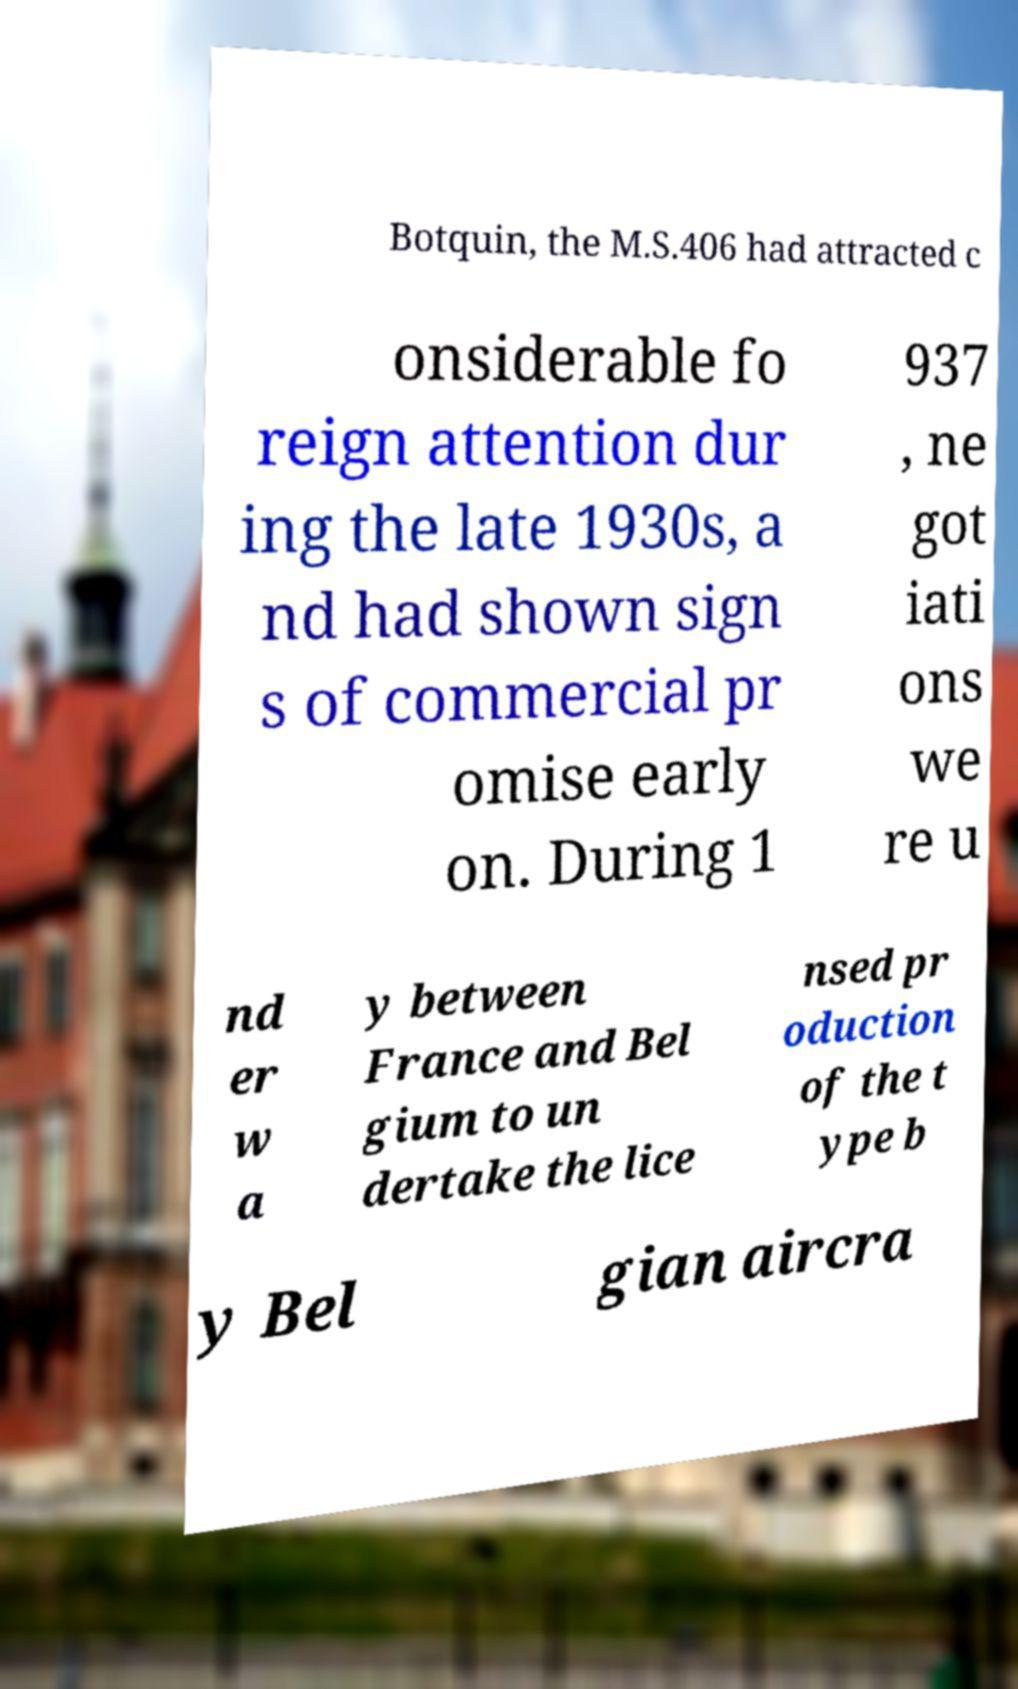Can you read and provide the text displayed in the image?This photo seems to have some interesting text. Can you extract and type it out for me? Botquin, the M.S.406 had attracted c onsiderable fo reign attention dur ing the late 1930s, a nd had shown sign s of commercial pr omise early on. During 1 937 , ne got iati ons we re u nd er w a y between France and Bel gium to un dertake the lice nsed pr oduction of the t ype b y Bel gian aircra 